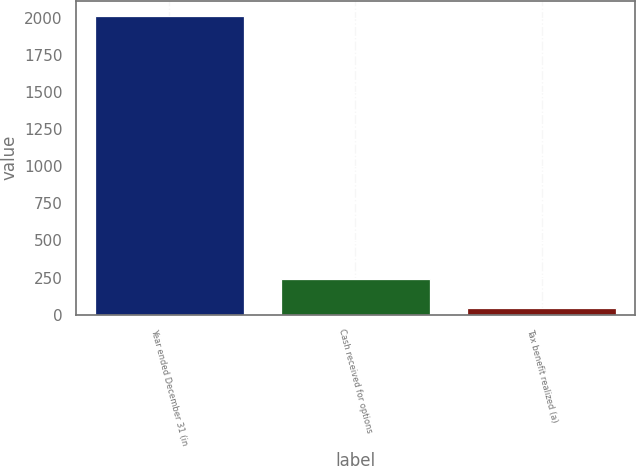<chart> <loc_0><loc_0><loc_500><loc_500><bar_chart><fcel>Year ended December 31 (in<fcel>Cash received for options<fcel>Tax benefit realized (a)<nl><fcel>2013<fcel>239.1<fcel>42<nl></chart> 